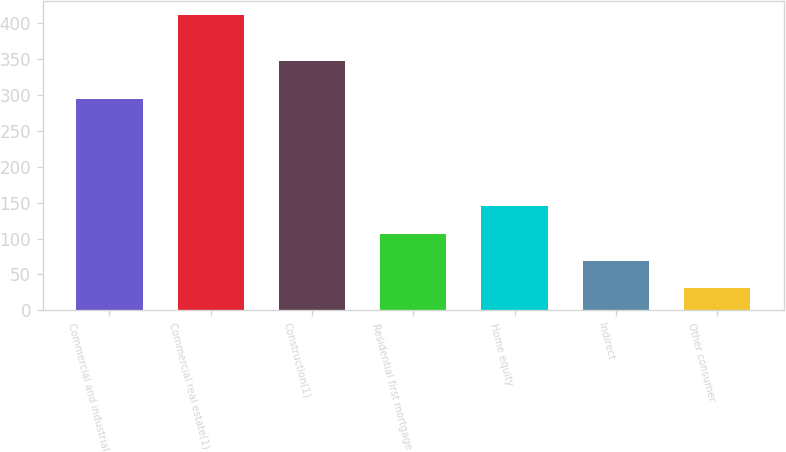<chart> <loc_0><loc_0><loc_500><loc_500><bar_chart><fcel>Commercial and industrial<fcel>Commercial real estate(1)<fcel>Construction(1)<fcel>Residential first mortgage<fcel>Home equity<fcel>Indirect<fcel>Other consumer<nl><fcel>295<fcel>411<fcel>348<fcel>107<fcel>145<fcel>69<fcel>31<nl></chart> 